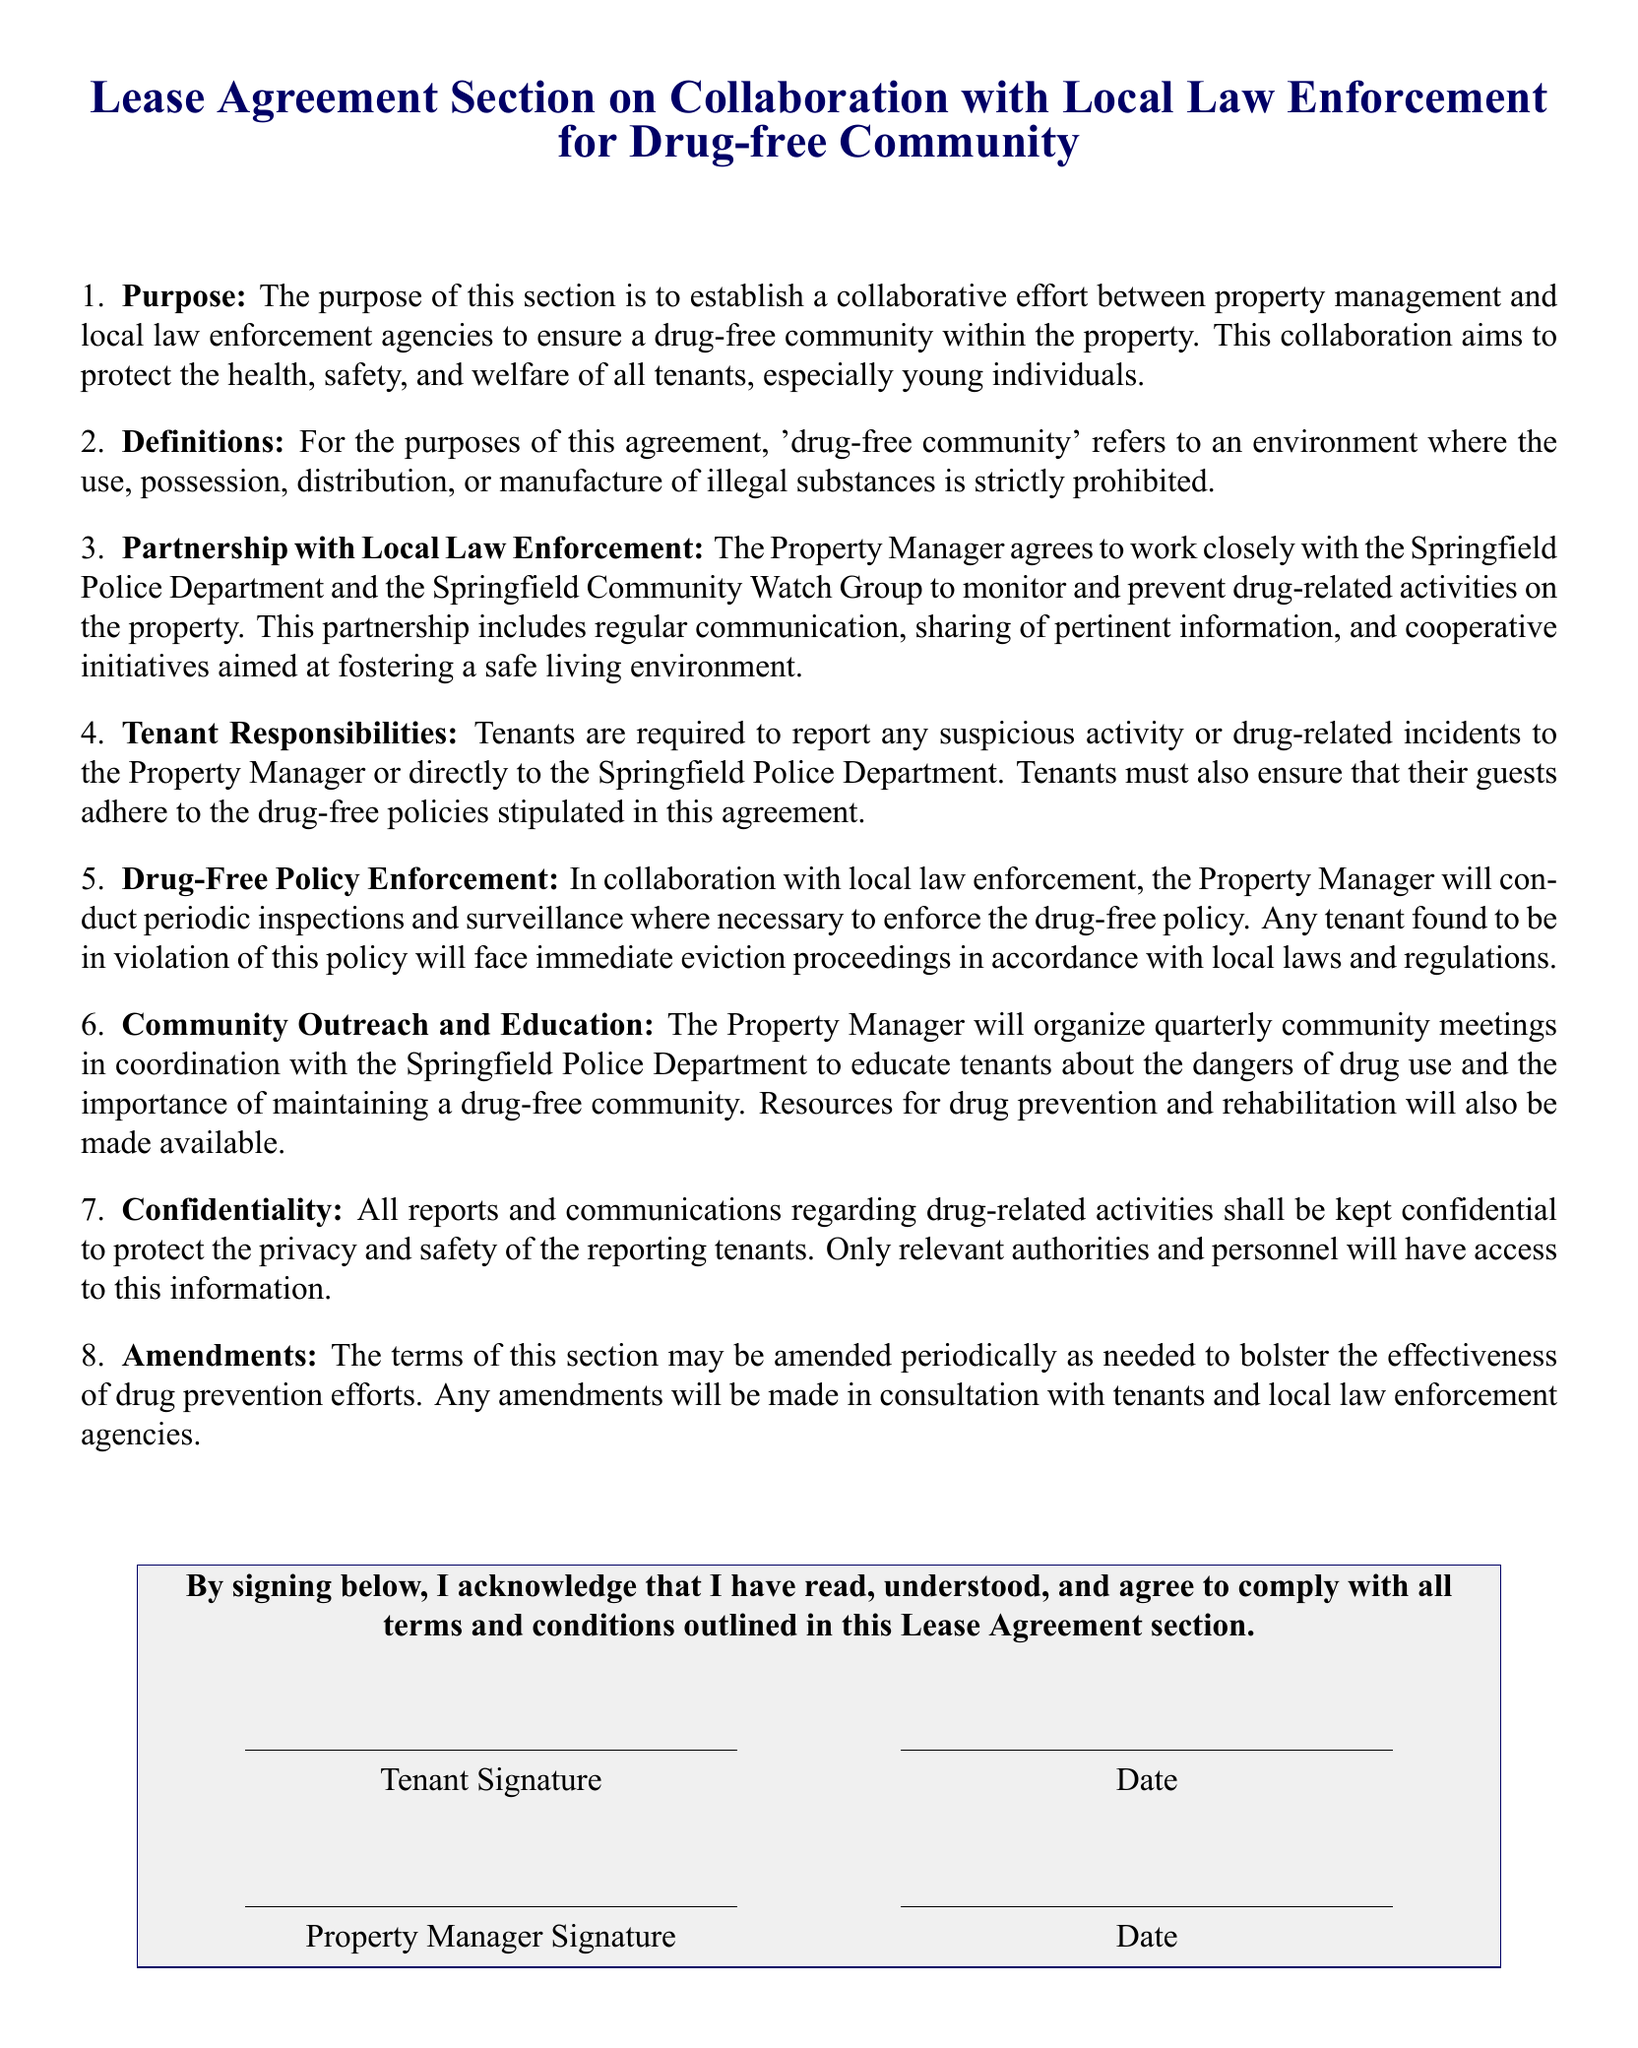What is the purpose of this section? The purpose of this section is to establish a collaborative effort between property management and local law enforcement agencies to ensure a drug-free community within the property.
Answer: Collaborative effort for a drug-free community What is defined as a 'drug-free community'? 'Drug-free community' refers to an environment where the use, possession, distribution, or manufacture of illegal substances is strictly prohibited.
Answer: Environment with no illegal substance Who does the Property Manager collaborate with? The Property Manager agrees to work closely with the Springfield Police Department and the Springfield Community Watch Group.
Answer: Springfield Police Department and Springfield Community Watch Group What must tenants do if they observe suspicious activity? Tenants are required to report any suspicious activity or drug-related incidents to the Property Manager or directly to the Springfield Police Department.
Answer: Report to Property Manager or police What are the consequences for violating the drug-free policy? Any tenant found to be in violation of this policy will face immediate eviction proceedings in accordance with local laws and regulations.
Answer: Immediate eviction proceedings How often will community meetings be organized? The Property Manager will organize quarterly community meetings in coordination with the Springfield Police Department.
Answer: Quarterly What is kept confidential in this agreement? All reports and communications regarding drug-related activities shall be kept confidential to protect the privacy and safety of the reporting tenants.
Answer: Reports and communications regarding drug-related activities What is required for amendments to this section? Any amendments will be made in consultation with tenants and local law enforcement agencies.
Answer: Consultation with tenants and local law enforcement agencies 